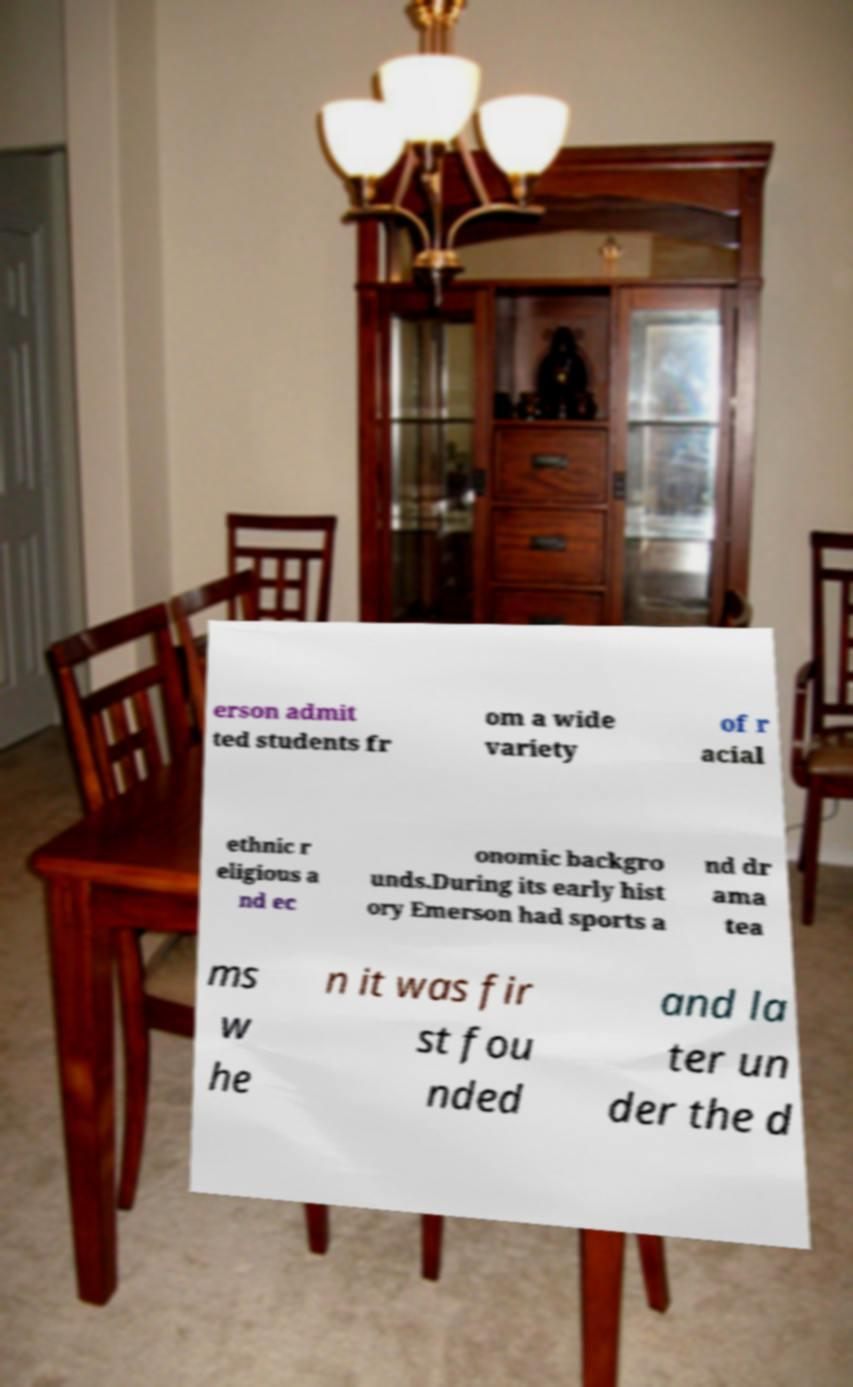There's text embedded in this image that I need extracted. Can you transcribe it verbatim? erson admit ted students fr om a wide variety of r acial ethnic r eligious a nd ec onomic backgro unds.During its early hist ory Emerson had sports a nd dr ama tea ms w he n it was fir st fou nded and la ter un der the d 